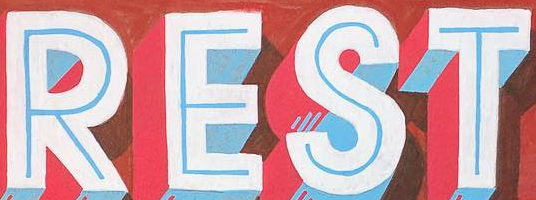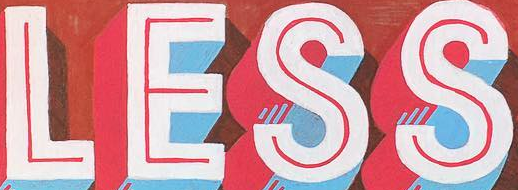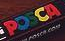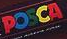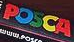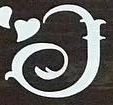What text appears in these images from left to right, separated by a semicolon? REST; LESS; POSCA; POSCA; POSCA; I 